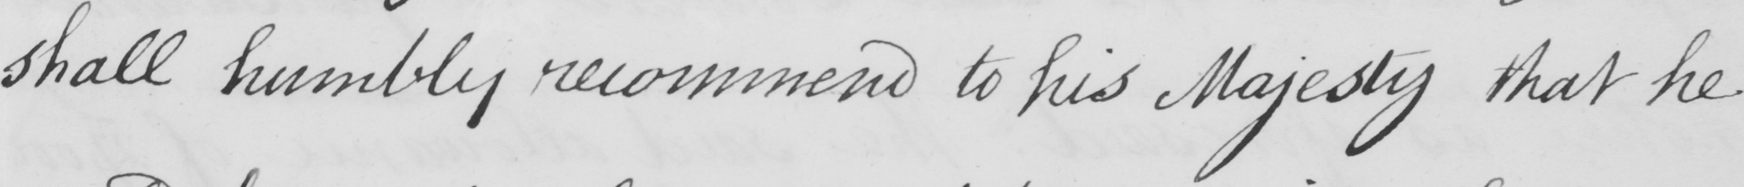What text is written in this handwritten line? shall humbly recommend to his Majesty that he 